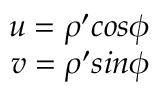Convert formula to latex. <formula><loc_0><loc_0><loc_500><loc_500>\begin{array} { r } { u = \rho ^ { \prime } \cos \phi } \\ { v = \rho ^ { \prime } \sin \phi } \end{array}</formula> 